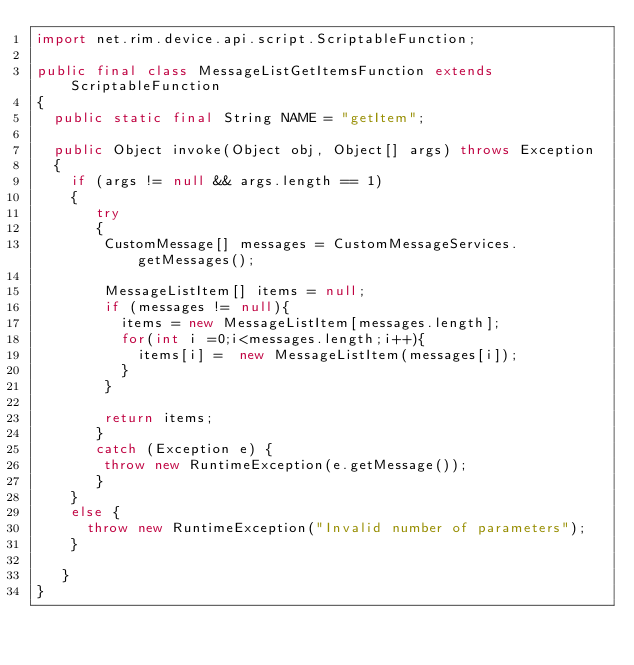<code> <loc_0><loc_0><loc_500><loc_500><_Java_>import net.rim.device.api.script.ScriptableFunction;
	
public final class MessageListGetItemsFunction extends ScriptableFunction
{
	public static final String NAME = "getItem";
	
	public Object invoke(Object obj, Object[] args) throws Exception
	{
		if (args != null && args.length == 1)
		{
		   try
		   {
				CustomMessage[] messages = CustomMessageServices.getMessages();

				MessageListItem[] items = null;
				if (messages != null){
					items = new MessageListItem[messages.length];
					for(int i =0;i<messages.length;i++){
						items[i] =  new MessageListItem(messages[i]);
					}
				}
				
				return items;		
		   } 
		   catch (Exception e) {
				throw new RuntimeException(e.getMessage());
		   }
		}
		else {
			throw new RuntimeException("Invalid number of parameters");
		}
		
	 }
}</code> 